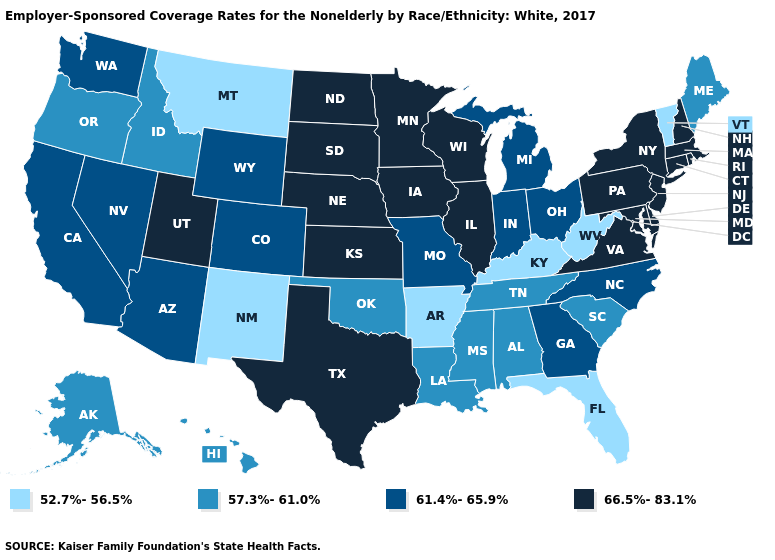Name the states that have a value in the range 61.4%-65.9%?
Be succinct. Arizona, California, Colorado, Georgia, Indiana, Michigan, Missouri, Nevada, North Carolina, Ohio, Washington, Wyoming. What is the value of New York?
Keep it brief. 66.5%-83.1%. Does Delaware have the highest value in the South?
Answer briefly. Yes. What is the highest value in states that border Georgia?
Quick response, please. 61.4%-65.9%. Name the states that have a value in the range 57.3%-61.0%?
Be succinct. Alabama, Alaska, Hawaii, Idaho, Louisiana, Maine, Mississippi, Oklahoma, Oregon, South Carolina, Tennessee. What is the value of Wyoming?
Quick response, please. 61.4%-65.9%. Does New Mexico have the lowest value in the West?
Quick response, please. Yes. What is the value of Kentucky?
Short answer required. 52.7%-56.5%. Does the map have missing data?
Quick response, please. No. What is the value of Maryland?
Be succinct. 66.5%-83.1%. Does Montana have the highest value in the USA?
Quick response, please. No. What is the lowest value in the West?
Quick response, please. 52.7%-56.5%. Does Florida have a higher value than Louisiana?
Quick response, please. No. What is the lowest value in states that border Nevada?
Answer briefly. 57.3%-61.0%. Which states hav the highest value in the Northeast?
Concise answer only. Connecticut, Massachusetts, New Hampshire, New Jersey, New York, Pennsylvania, Rhode Island. 